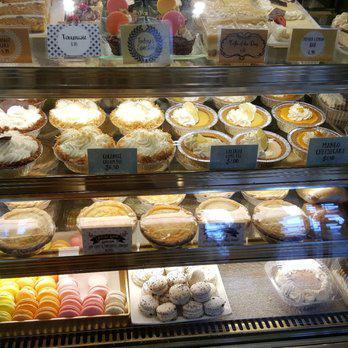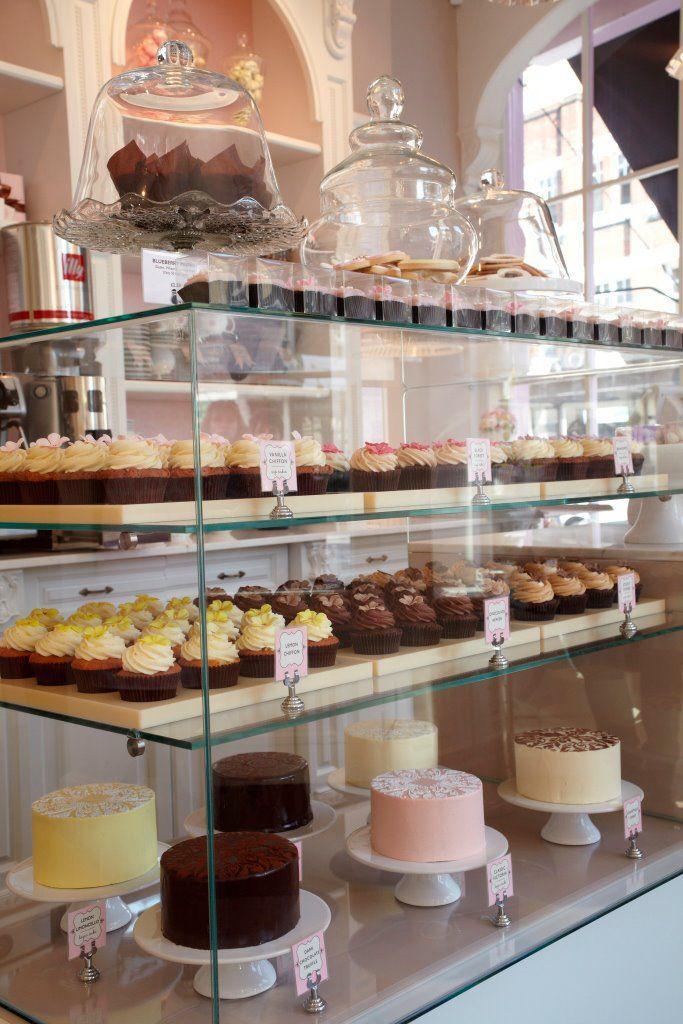The first image is the image on the left, the second image is the image on the right. For the images shown, is this caption "The floor can be seen in one of the images." true? Answer yes or no. No. 